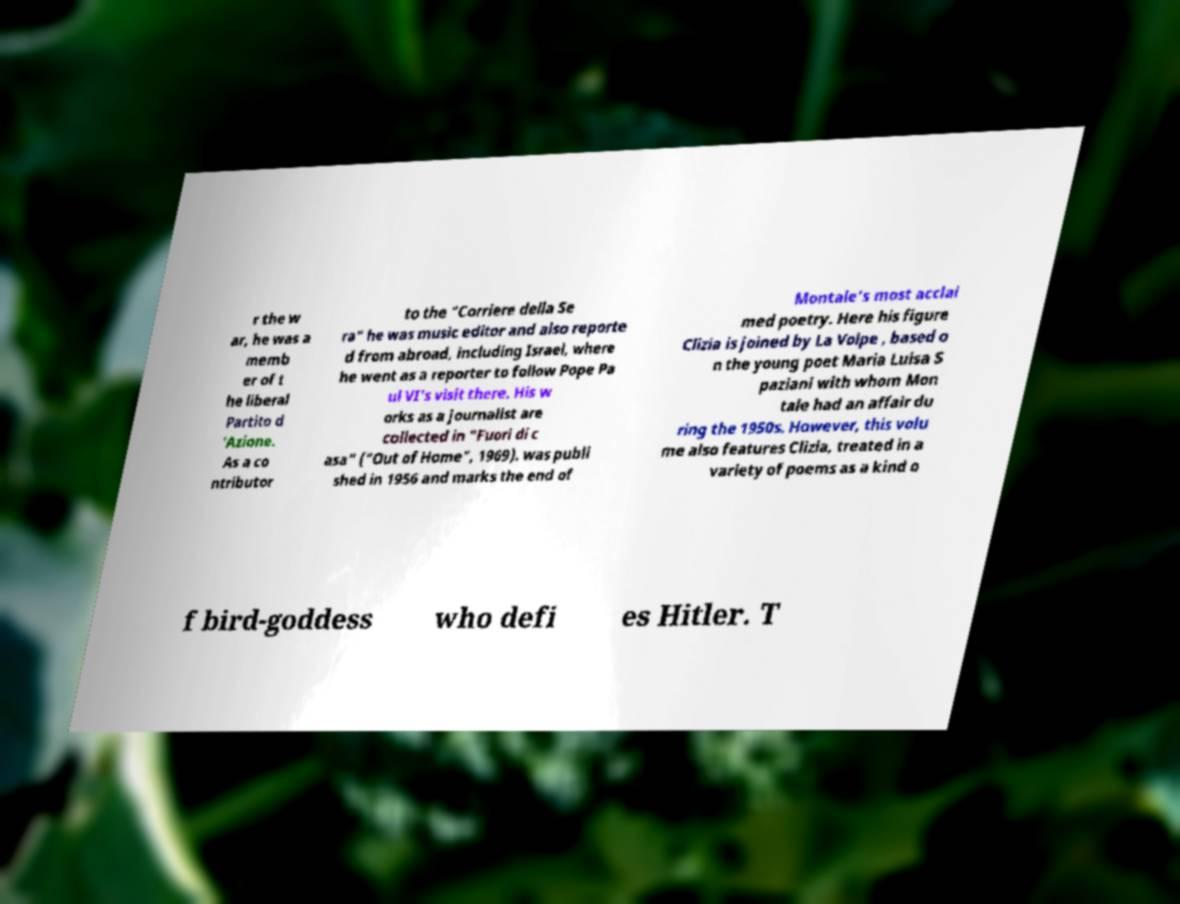Can you accurately transcribe the text from the provided image for me? r the w ar, he was a memb er of t he liberal Partito d 'Azione. As a co ntributor to the "Corriere della Se ra" he was music editor and also reporte d from abroad, including Israel, where he went as a reporter to follow Pope Pa ul VI's visit there. His w orks as a journalist are collected in "Fuori di c asa" ("Out of Home", 1969). was publi shed in 1956 and marks the end of Montale's most acclai med poetry. Here his figure Clizia is joined by La Volpe , based o n the young poet Maria Luisa S paziani with whom Mon tale had an affair du ring the 1950s. However, this volu me also features Clizia, treated in a variety of poems as a kind o f bird-goddess who defi es Hitler. T 